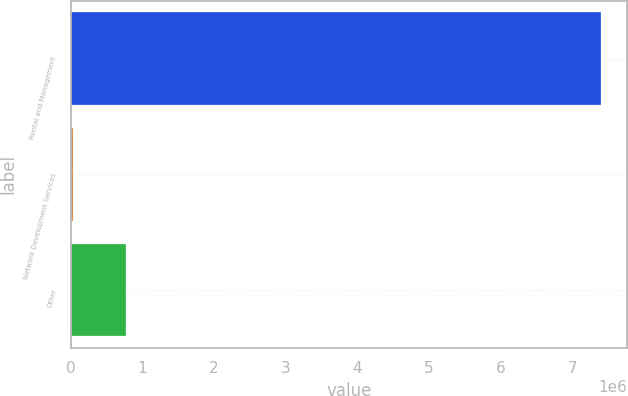Convert chart to OTSL. <chart><loc_0><loc_0><loc_500><loc_500><bar_chart><fcel>Rental and Management<fcel>Network Development Services<fcel>Other<nl><fcel>7.39858e+06<fcel>30263<fcel>767095<nl></chart> 